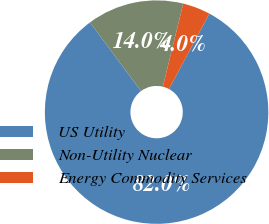<chart> <loc_0><loc_0><loc_500><loc_500><pie_chart><fcel>US Utility<fcel>Non-Utility Nuclear<fcel>Energy Commodity Services<nl><fcel>82.0%<fcel>14.0%<fcel>4.0%<nl></chart> 